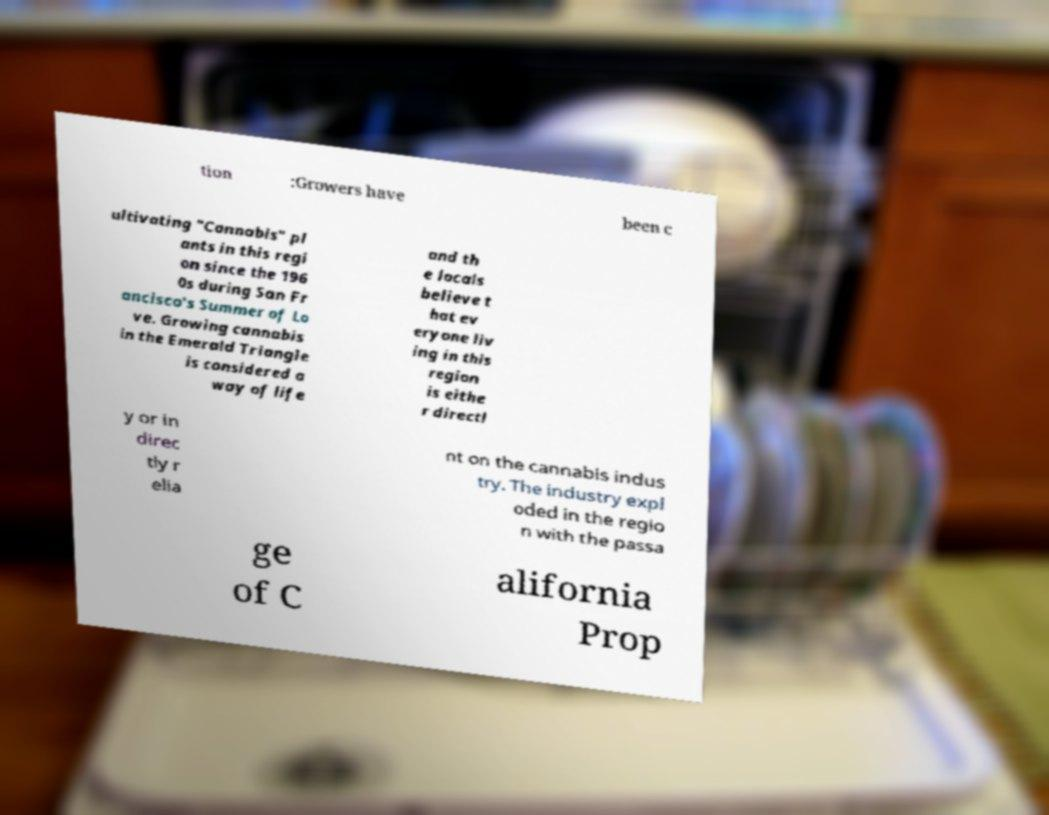There's text embedded in this image that I need extracted. Can you transcribe it verbatim? tion :Growers have been c ultivating "Cannabis" pl ants in this regi on since the 196 0s during San Fr ancisco's Summer of Lo ve. Growing cannabis in the Emerald Triangle is considered a way of life and th e locals believe t hat ev eryone liv ing in this region is eithe r directl y or in direc tly r elia nt on the cannabis indus try. The industry expl oded in the regio n with the passa ge of C alifornia Prop 